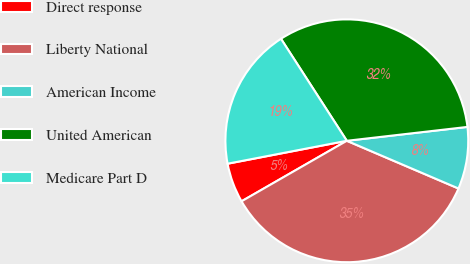<chart> <loc_0><loc_0><loc_500><loc_500><pie_chart><fcel>Direct response<fcel>Liberty National<fcel>American Income<fcel>United American<fcel>Medicare Part D<nl><fcel>5.28%<fcel>35.27%<fcel>8.25%<fcel>32.3%<fcel>18.9%<nl></chart> 